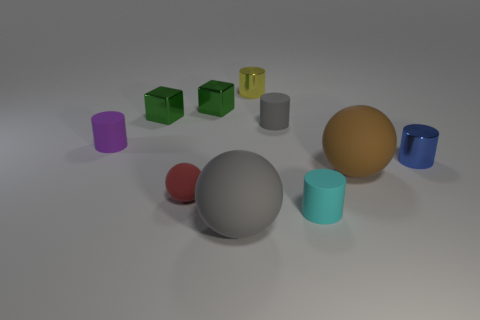Subtract 1 cylinders. How many cylinders are left? 4 Subtract all blue cylinders. How many cylinders are left? 4 Subtract all green cylinders. Subtract all brown balls. How many cylinders are left? 5 Subtract all blocks. How many objects are left? 8 Add 2 purple cylinders. How many purple cylinders are left? 3 Add 6 small metallic blocks. How many small metallic blocks exist? 8 Subtract 0 red cylinders. How many objects are left? 10 Subtract all purple objects. Subtract all rubber balls. How many objects are left? 6 